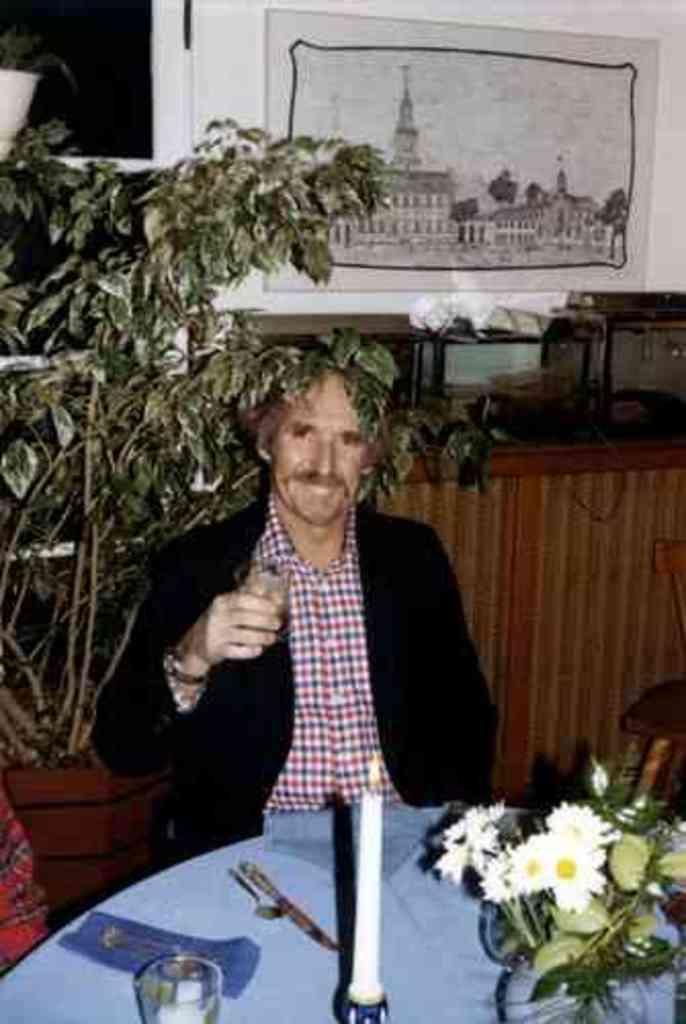Describe this image in one or two sentences. This picture shows a man seated on the chair holding a glass in his hand and we see a candle and a flower pot and we see spoon and knife and another glass on the table and we see a chair on the side and we see a plant and frame on the wall and we see cupboard on the side. 